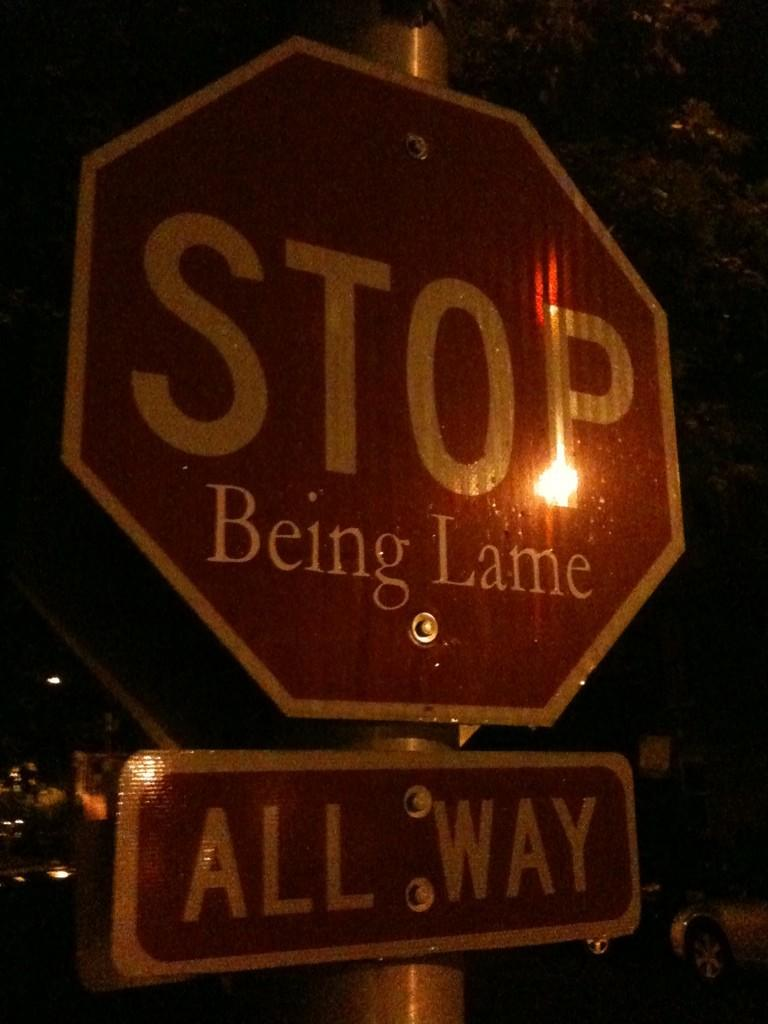<image>
Relay a brief, clear account of the picture shown. The phrase "being lame" is written on a stop sign. 